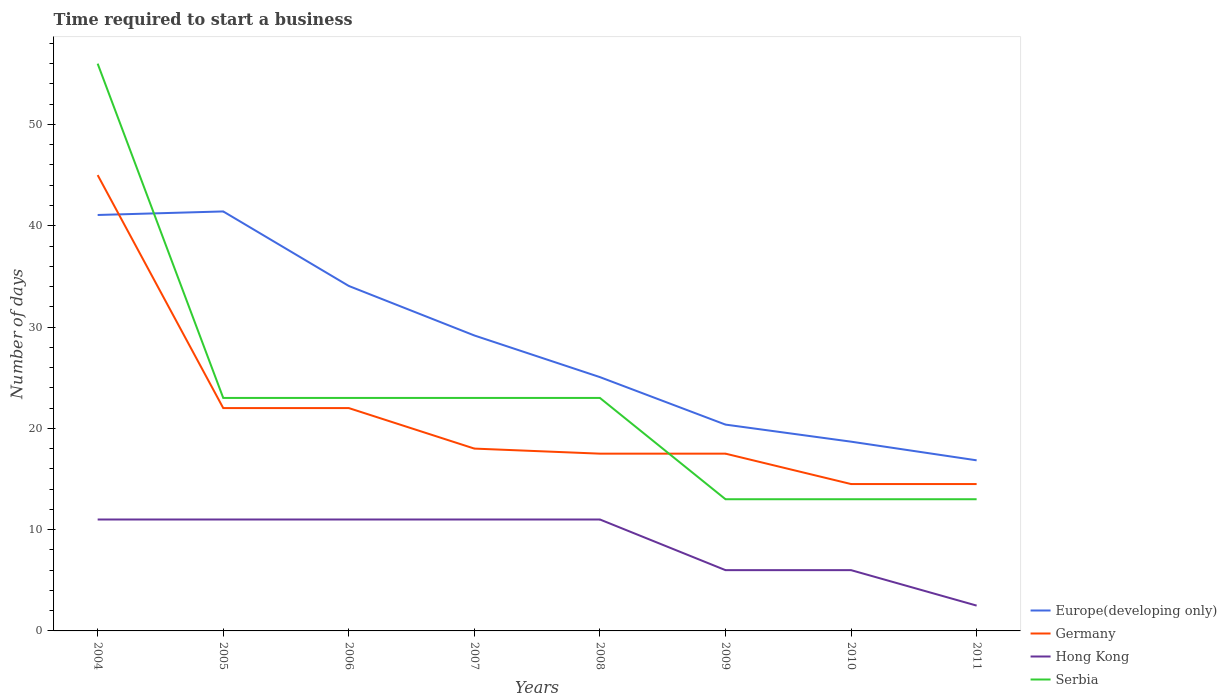How many different coloured lines are there?
Ensure brevity in your answer.  4. Is the number of lines equal to the number of legend labels?
Your response must be concise. Yes. Across all years, what is the maximum number of days required to start a business in Serbia?
Offer a terse response. 13. What is the total number of days required to start a business in Europe(developing only) in the graph?
Make the answer very short. 17.21. What is the difference between the highest and the second highest number of days required to start a business in Serbia?
Provide a succinct answer. 43. What is the difference between the highest and the lowest number of days required to start a business in Europe(developing only)?
Ensure brevity in your answer.  4. Is the number of days required to start a business in Hong Kong strictly greater than the number of days required to start a business in Serbia over the years?
Make the answer very short. Yes. How many lines are there?
Provide a succinct answer. 4. How many years are there in the graph?
Provide a short and direct response. 8. Are the values on the major ticks of Y-axis written in scientific E-notation?
Offer a terse response. No. Does the graph contain any zero values?
Give a very brief answer. No. How many legend labels are there?
Keep it short and to the point. 4. How are the legend labels stacked?
Offer a terse response. Vertical. What is the title of the graph?
Offer a very short reply. Time required to start a business. What is the label or title of the Y-axis?
Give a very brief answer. Number of days. What is the Number of days of Europe(developing only) in 2004?
Your response must be concise. 41.06. What is the Number of days in Hong Kong in 2004?
Offer a very short reply. 11. What is the Number of days in Europe(developing only) in 2005?
Offer a very short reply. 41.41. What is the Number of days in Germany in 2005?
Offer a terse response. 22. What is the Number of days of Europe(developing only) in 2006?
Provide a short and direct response. 34.06. What is the Number of days of Hong Kong in 2006?
Your answer should be compact. 11. What is the Number of days of Europe(developing only) in 2007?
Make the answer very short. 29.17. What is the Number of days in Hong Kong in 2007?
Give a very brief answer. 11. What is the Number of days in Europe(developing only) in 2008?
Your answer should be compact. 25.06. What is the Number of days in Hong Kong in 2008?
Make the answer very short. 11. What is the Number of days in Europe(developing only) in 2009?
Give a very brief answer. 20.37. What is the Number of days in Germany in 2009?
Ensure brevity in your answer.  17.5. What is the Number of days in Europe(developing only) in 2010?
Your answer should be very brief. 18.68. What is the Number of days in Hong Kong in 2010?
Provide a succinct answer. 6. What is the Number of days of Europe(developing only) in 2011?
Offer a terse response. 16.84. What is the Number of days of Germany in 2011?
Offer a very short reply. 14.5. What is the Number of days of Serbia in 2011?
Keep it short and to the point. 13. Across all years, what is the maximum Number of days of Europe(developing only)?
Make the answer very short. 41.41. Across all years, what is the maximum Number of days in Germany?
Keep it short and to the point. 45. Across all years, what is the minimum Number of days of Europe(developing only)?
Your answer should be compact. 16.84. Across all years, what is the minimum Number of days of Germany?
Ensure brevity in your answer.  14.5. What is the total Number of days of Europe(developing only) in the graph?
Provide a succinct answer. 226.65. What is the total Number of days in Germany in the graph?
Keep it short and to the point. 171. What is the total Number of days in Hong Kong in the graph?
Your answer should be compact. 69.5. What is the total Number of days of Serbia in the graph?
Give a very brief answer. 187. What is the difference between the Number of days in Europe(developing only) in 2004 and that in 2005?
Offer a very short reply. -0.35. What is the difference between the Number of days of Germany in 2004 and that in 2005?
Offer a terse response. 23. What is the difference between the Number of days in Hong Kong in 2004 and that in 2005?
Keep it short and to the point. 0. What is the difference between the Number of days of Europe(developing only) in 2004 and that in 2006?
Ensure brevity in your answer.  7.01. What is the difference between the Number of days of Germany in 2004 and that in 2006?
Provide a short and direct response. 23. What is the difference between the Number of days of Hong Kong in 2004 and that in 2006?
Keep it short and to the point. 0. What is the difference between the Number of days in Europe(developing only) in 2004 and that in 2007?
Your answer should be compact. 11.9. What is the difference between the Number of days of Europe(developing only) in 2004 and that in 2008?
Make the answer very short. 16.01. What is the difference between the Number of days of Germany in 2004 and that in 2008?
Keep it short and to the point. 27.5. What is the difference between the Number of days in Europe(developing only) in 2004 and that in 2009?
Provide a succinct answer. 20.69. What is the difference between the Number of days in Germany in 2004 and that in 2009?
Your answer should be very brief. 27.5. What is the difference between the Number of days in Hong Kong in 2004 and that in 2009?
Offer a very short reply. 5. What is the difference between the Number of days in Serbia in 2004 and that in 2009?
Offer a terse response. 43. What is the difference between the Number of days in Europe(developing only) in 2004 and that in 2010?
Provide a short and direct response. 22.38. What is the difference between the Number of days in Germany in 2004 and that in 2010?
Offer a very short reply. 30.5. What is the difference between the Number of days of Hong Kong in 2004 and that in 2010?
Provide a succinct answer. 5. What is the difference between the Number of days of Europe(developing only) in 2004 and that in 2011?
Offer a very short reply. 24.22. What is the difference between the Number of days in Germany in 2004 and that in 2011?
Your answer should be very brief. 30.5. What is the difference between the Number of days of Serbia in 2004 and that in 2011?
Offer a terse response. 43. What is the difference between the Number of days in Europe(developing only) in 2005 and that in 2006?
Make the answer very short. 7.36. What is the difference between the Number of days in Hong Kong in 2005 and that in 2006?
Ensure brevity in your answer.  0. What is the difference between the Number of days in Serbia in 2005 and that in 2006?
Your response must be concise. 0. What is the difference between the Number of days of Europe(developing only) in 2005 and that in 2007?
Your answer should be very brief. 12.25. What is the difference between the Number of days of Germany in 2005 and that in 2007?
Keep it short and to the point. 4. What is the difference between the Number of days of Hong Kong in 2005 and that in 2007?
Offer a very short reply. 0. What is the difference between the Number of days in Serbia in 2005 and that in 2007?
Give a very brief answer. 0. What is the difference between the Number of days in Europe(developing only) in 2005 and that in 2008?
Provide a succinct answer. 16.36. What is the difference between the Number of days of Germany in 2005 and that in 2008?
Your answer should be compact. 4.5. What is the difference between the Number of days of Europe(developing only) in 2005 and that in 2009?
Your answer should be compact. 21.04. What is the difference between the Number of days in Europe(developing only) in 2005 and that in 2010?
Ensure brevity in your answer.  22.73. What is the difference between the Number of days of Germany in 2005 and that in 2010?
Offer a terse response. 7.5. What is the difference between the Number of days in Europe(developing only) in 2005 and that in 2011?
Provide a short and direct response. 24.57. What is the difference between the Number of days of Serbia in 2005 and that in 2011?
Your response must be concise. 10. What is the difference between the Number of days in Europe(developing only) in 2006 and that in 2007?
Provide a short and direct response. 4.89. What is the difference between the Number of days in Serbia in 2006 and that in 2007?
Provide a succinct answer. 0. What is the difference between the Number of days in Europe(developing only) in 2006 and that in 2008?
Your response must be concise. 9. What is the difference between the Number of days in Germany in 2006 and that in 2008?
Keep it short and to the point. 4.5. What is the difference between the Number of days in Hong Kong in 2006 and that in 2008?
Your answer should be compact. 0. What is the difference between the Number of days of Europe(developing only) in 2006 and that in 2009?
Make the answer very short. 13.69. What is the difference between the Number of days of Serbia in 2006 and that in 2009?
Provide a short and direct response. 10. What is the difference between the Number of days of Europe(developing only) in 2006 and that in 2010?
Make the answer very short. 15.37. What is the difference between the Number of days of Hong Kong in 2006 and that in 2010?
Provide a short and direct response. 5. What is the difference between the Number of days of Europe(developing only) in 2006 and that in 2011?
Make the answer very short. 17.21. What is the difference between the Number of days of Germany in 2006 and that in 2011?
Make the answer very short. 7.5. What is the difference between the Number of days of Hong Kong in 2006 and that in 2011?
Provide a succinct answer. 8.5. What is the difference between the Number of days of Europe(developing only) in 2007 and that in 2008?
Your response must be concise. 4.11. What is the difference between the Number of days in Germany in 2007 and that in 2008?
Give a very brief answer. 0.5. What is the difference between the Number of days of Hong Kong in 2007 and that in 2008?
Your response must be concise. 0. What is the difference between the Number of days of Serbia in 2007 and that in 2008?
Ensure brevity in your answer.  0. What is the difference between the Number of days of Europe(developing only) in 2007 and that in 2009?
Provide a succinct answer. 8.8. What is the difference between the Number of days in Serbia in 2007 and that in 2009?
Keep it short and to the point. 10. What is the difference between the Number of days of Europe(developing only) in 2007 and that in 2010?
Offer a terse response. 10.48. What is the difference between the Number of days in Hong Kong in 2007 and that in 2010?
Your response must be concise. 5. What is the difference between the Number of days in Europe(developing only) in 2007 and that in 2011?
Make the answer very short. 12.32. What is the difference between the Number of days of Serbia in 2007 and that in 2011?
Make the answer very short. 10. What is the difference between the Number of days in Europe(developing only) in 2008 and that in 2009?
Keep it short and to the point. 4.69. What is the difference between the Number of days of Europe(developing only) in 2008 and that in 2010?
Offer a terse response. 6.37. What is the difference between the Number of days in Europe(developing only) in 2008 and that in 2011?
Your answer should be compact. 8.21. What is the difference between the Number of days in Germany in 2008 and that in 2011?
Offer a very short reply. 3. What is the difference between the Number of days of Hong Kong in 2008 and that in 2011?
Offer a very short reply. 8.5. What is the difference between the Number of days of Europe(developing only) in 2009 and that in 2010?
Offer a very short reply. 1.68. What is the difference between the Number of days in Europe(developing only) in 2009 and that in 2011?
Your response must be concise. 3.53. What is the difference between the Number of days in Germany in 2009 and that in 2011?
Your answer should be very brief. 3. What is the difference between the Number of days in Europe(developing only) in 2010 and that in 2011?
Keep it short and to the point. 1.84. What is the difference between the Number of days of Germany in 2010 and that in 2011?
Ensure brevity in your answer.  0. What is the difference between the Number of days in Europe(developing only) in 2004 and the Number of days in Germany in 2005?
Provide a succinct answer. 19.06. What is the difference between the Number of days in Europe(developing only) in 2004 and the Number of days in Hong Kong in 2005?
Make the answer very short. 30.06. What is the difference between the Number of days of Europe(developing only) in 2004 and the Number of days of Serbia in 2005?
Your answer should be compact. 18.06. What is the difference between the Number of days of Germany in 2004 and the Number of days of Hong Kong in 2005?
Keep it short and to the point. 34. What is the difference between the Number of days of Germany in 2004 and the Number of days of Serbia in 2005?
Your answer should be compact. 22. What is the difference between the Number of days of Europe(developing only) in 2004 and the Number of days of Germany in 2006?
Give a very brief answer. 19.06. What is the difference between the Number of days in Europe(developing only) in 2004 and the Number of days in Hong Kong in 2006?
Provide a short and direct response. 30.06. What is the difference between the Number of days in Europe(developing only) in 2004 and the Number of days in Serbia in 2006?
Provide a succinct answer. 18.06. What is the difference between the Number of days in Germany in 2004 and the Number of days in Serbia in 2006?
Your response must be concise. 22. What is the difference between the Number of days in Hong Kong in 2004 and the Number of days in Serbia in 2006?
Offer a very short reply. -12. What is the difference between the Number of days in Europe(developing only) in 2004 and the Number of days in Germany in 2007?
Give a very brief answer. 23.06. What is the difference between the Number of days in Europe(developing only) in 2004 and the Number of days in Hong Kong in 2007?
Make the answer very short. 30.06. What is the difference between the Number of days in Europe(developing only) in 2004 and the Number of days in Serbia in 2007?
Make the answer very short. 18.06. What is the difference between the Number of days of Germany in 2004 and the Number of days of Hong Kong in 2007?
Your answer should be very brief. 34. What is the difference between the Number of days in Germany in 2004 and the Number of days in Serbia in 2007?
Provide a succinct answer. 22. What is the difference between the Number of days of Europe(developing only) in 2004 and the Number of days of Germany in 2008?
Your answer should be compact. 23.56. What is the difference between the Number of days in Europe(developing only) in 2004 and the Number of days in Hong Kong in 2008?
Your answer should be very brief. 30.06. What is the difference between the Number of days in Europe(developing only) in 2004 and the Number of days in Serbia in 2008?
Ensure brevity in your answer.  18.06. What is the difference between the Number of days in Germany in 2004 and the Number of days in Hong Kong in 2008?
Offer a terse response. 34. What is the difference between the Number of days in Hong Kong in 2004 and the Number of days in Serbia in 2008?
Your answer should be very brief. -12. What is the difference between the Number of days of Europe(developing only) in 2004 and the Number of days of Germany in 2009?
Make the answer very short. 23.56. What is the difference between the Number of days in Europe(developing only) in 2004 and the Number of days in Hong Kong in 2009?
Offer a very short reply. 35.06. What is the difference between the Number of days of Europe(developing only) in 2004 and the Number of days of Serbia in 2009?
Your response must be concise. 28.06. What is the difference between the Number of days in Europe(developing only) in 2004 and the Number of days in Germany in 2010?
Offer a very short reply. 26.56. What is the difference between the Number of days of Europe(developing only) in 2004 and the Number of days of Hong Kong in 2010?
Offer a very short reply. 35.06. What is the difference between the Number of days in Europe(developing only) in 2004 and the Number of days in Serbia in 2010?
Offer a very short reply. 28.06. What is the difference between the Number of days in Germany in 2004 and the Number of days in Hong Kong in 2010?
Provide a succinct answer. 39. What is the difference between the Number of days of Germany in 2004 and the Number of days of Serbia in 2010?
Your answer should be compact. 32. What is the difference between the Number of days of Europe(developing only) in 2004 and the Number of days of Germany in 2011?
Your answer should be compact. 26.56. What is the difference between the Number of days of Europe(developing only) in 2004 and the Number of days of Hong Kong in 2011?
Your answer should be compact. 38.56. What is the difference between the Number of days of Europe(developing only) in 2004 and the Number of days of Serbia in 2011?
Ensure brevity in your answer.  28.06. What is the difference between the Number of days in Germany in 2004 and the Number of days in Hong Kong in 2011?
Ensure brevity in your answer.  42.5. What is the difference between the Number of days of Hong Kong in 2004 and the Number of days of Serbia in 2011?
Keep it short and to the point. -2. What is the difference between the Number of days in Europe(developing only) in 2005 and the Number of days in Germany in 2006?
Your answer should be very brief. 19.41. What is the difference between the Number of days of Europe(developing only) in 2005 and the Number of days of Hong Kong in 2006?
Your answer should be very brief. 30.41. What is the difference between the Number of days of Europe(developing only) in 2005 and the Number of days of Serbia in 2006?
Provide a succinct answer. 18.41. What is the difference between the Number of days in Hong Kong in 2005 and the Number of days in Serbia in 2006?
Keep it short and to the point. -12. What is the difference between the Number of days in Europe(developing only) in 2005 and the Number of days in Germany in 2007?
Provide a succinct answer. 23.41. What is the difference between the Number of days of Europe(developing only) in 2005 and the Number of days of Hong Kong in 2007?
Offer a terse response. 30.41. What is the difference between the Number of days of Europe(developing only) in 2005 and the Number of days of Serbia in 2007?
Offer a terse response. 18.41. What is the difference between the Number of days of Germany in 2005 and the Number of days of Hong Kong in 2007?
Your answer should be compact. 11. What is the difference between the Number of days of Europe(developing only) in 2005 and the Number of days of Germany in 2008?
Offer a terse response. 23.91. What is the difference between the Number of days in Europe(developing only) in 2005 and the Number of days in Hong Kong in 2008?
Keep it short and to the point. 30.41. What is the difference between the Number of days in Europe(developing only) in 2005 and the Number of days in Serbia in 2008?
Provide a succinct answer. 18.41. What is the difference between the Number of days of Germany in 2005 and the Number of days of Hong Kong in 2008?
Provide a succinct answer. 11. What is the difference between the Number of days of Europe(developing only) in 2005 and the Number of days of Germany in 2009?
Ensure brevity in your answer.  23.91. What is the difference between the Number of days of Europe(developing only) in 2005 and the Number of days of Hong Kong in 2009?
Give a very brief answer. 35.41. What is the difference between the Number of days in Europe(developing only) in 2005 and the Number of days in Serbia in 2009?
Your response must be concise. 28.41. What is the difference between the Number of days of Germany in 2005 and the Number of days of Hong Kong in 2009?
Offer a very short reply. 16. What is the difference between the Number of days of Germany in 2005 and the Number of days of Serbia in 2009?
Your answer should be very brief. 9. What is the difference between the Number of days of Hong Kong in 2005 and the Number of days of Serbia in 2009?
Your answer should be compact. -2. What is the difference between the Number of days of Europe(developing only) in 2005 and the Number of days of Germany in 2010?
Keep it short and to the point. 26.91. What is the difference between the Number of days in Europe(developing only) in 2005 and the Number of days in Hong Kong in 2010?
Your response must be concise. 35.41. What is the difference between the Number of days in Europe(developing only) in 2005 and the Number of days in Serbia in 2010?
Offer a terse response. 28.41. What is the difference between the Number of days of Hong Kong in 2005 and the Number of days of Serbia in 2010?
Provide a succinct answer. -2. What is the difference between the Number of days in Europe(developing only) in 2005 and the Number of days in Germany in 2011?
Make the answer very short. 26.91. What is the difference between the Number of days in Europe(developing only) in 2005 and the Number of days in Hong Kong in 2011?
Your answer should be compact. 38.91. What is the difference between the Number of days of Europe(developing only) in 2005 and the Number of days of Serbia in 2011?
Offer a terse response. 28.41. What is the difference between the Number of days of Germany in 2005 and the Number of days of Hong Kong in 2011?
Ensure brevity in your answer.  19.5. What is the difference between the Number of days in Germany in 2005 and the Number of days in Serbia in 2011?
Your answer should be very brief. 9. What is the difference between the Number of days in Europe(developing only) in 2006 and the Number of days in Germany in 2007?
Make the answer very short. 16.06. What is the difference between the Number of days of Europe(developing only) in 2006 and the Number of days of Hong Kong in 2007?
Your answer should be compact. 23.06. What is the difference between the Number of days of Europe(developing only) in 2006 and the Number of days of Serbia in 2007?
Keep it short and to the point. 11.06. What is the difference between the Number of days of Hong Kong in 2006 and the Number of days of Serbia in 2007?
Your answer should be very brief. -12. What is the difference between the Number of days in Europe(developing only) in 2006 and the Number of days in Germany in 2008?
Offer a very short reply. 16.56. What is the difference between the Number of days of Europe(developing only) in 2006 and the Number of days of Hong Kong in 2008?
Keep it short and to the point. 23.06. What is the difference between the Number of days in Europe(developing only) in 2006 and the Number of days in Serbia in 2008?
Ensure brevity in your answer.  11.06. What is the difference between the Number of days of Germany in 2006 and the Number of days of Serbia in 2008?
Offer a terse response. -1. What is the difference between the Number of days in Hong Kong in 2006 and the Number of days in Serbia in 2008?
Offer a very short reply. -12. What is the difference between the Number of days of Europe(developing only) in 2006 and the Number of days of Germany in 2009?
Keep it short and to the point. 16.56. What is the difference between the Number of days of Europe(developing only) in 2006 and the Number of days of Hong Kong in 2009?
Your response must be concise. 28.06. What is the difference between the Number of days of Europe(developing only) in 2006 and the Number of days of Serbia in 2009?
Provide a succinct answer. 21.06. What is the difference between the Number of days in Germany in 2006 and the Number of days in Hong Kong in 2009?
Offer a very short reply. 16. What is the difference between the Number of days in Germany in 2006 and the Number of days in Serbia in 2009?
Provide a short and direct response. 9. What is the difference between the Number of days of Hong Kong in 2006 and the Number of days of Serbia in 2009?
Provide a short and direct response. -2. What is the difference between the Number of days of Europe(developing only) in 2006 and the Number of days of Germany in 2010?
Your answer should be compact. 19.56. What is the difference between the Number of days of Europe(developing only) in 2006 and the Number of days of Hong Kong in 2010?
Provide a succinct answer. 28.06. What is the difference between the Number of days in Europe(developing only) in 2006 and the Number of days in Serbia in 2010?
Keep it short and to the point. 21.06. What is the difference between the Number of days of Germany in 2006 and the Number of days of Serbia in 2010?
Keep it short and to the point. 9. What is the difference between the Number of days of Hong Kong in 2006 and the Number of days of Serbia in 2010?
Ensure brevity in your answer.  -2. What is the difference between the Number of days in Europe(developing only) in 2006 and the Number of days in Germany in 2011?
Make the answer very short. 19.56. What is the difference between the Number of days in Europe(developing only) in 2006 and the Number of days in Hong Kong in 2011?
Make the answer very short. 31.56. What is the difference between the Number of days in Europe(developing only) in 2006 and the Number of days in Serbia in 2011?
Your answer should be compact. 21.06. What is the difference between the Number of days in Europe(developing only) in 2007 and the Number of days in Germany in 2008?
Give a very brief answer. 11.67. What is the difference between the Number of days in Europe(developing only) in 2007 and the Number of days in Hong Kong in 2008?
Keep it short and to the point. 18.17. What is the difference between the Number of days in Europe(developing only) in 2007 and the Number of days in Serbia in 2008?
Offer a terse response. 6.17. What is the difference between the Number of days in Hong Kong in 2007 and the Number of days in Serbia in 2008?
Give a very brief answer. -12. What is the difference between the Number of days of Europe(developing only) in 2007 and the Number of days of Germany in 2009?
Offer a very short reply. 11.67. What is the difference between the Number of days of Europe(developing only) in 2007 and the Number of days of Hong Kong in 2009?
Keep it short and to the point. 23.17. What is the difference between the Number of days in Europe(developing only) in 2007 and the Number of days in Serbia in 2009?
Keep it short and to the point. 16.17. What is the difference between the Number of days in Germany in 2007 and the Number of days in Hong Kong in 2009?
Your answer should be compact. 12. What is the difference between the Number of days of Germany in 2007 and the Number of days of Serbia in 2009?
Give a very brief answer. 5. What is the difference between the Number of days in Europe(developing only) in 2007 and the Number of days in Germany in 2010?
Make the answer very short. 14.67. What is the difference between the Number of days of Europe(developing only) in 2007 and the Number of days of Hong Kong in 2010?
Your answer should be compact. 23.17. What is the difference between the Number of days in Europe(developing only) in 2007 and the Number of days in Serbia in 2010?
Provide a short and direct response. 16.17. What is the difference between the Number of days of Germany in 2007 and the Number of days of Hong Kong in 2010?
Keep it short and to the point. 12. What is the difference between the Number of days of Europe(developing only) in 2007 and the Number of days of Germany in 2011?
Your response must be concise. 14.67. What is the difference between the Number of days of Europe(developing only) in 2007 and the Number of days of Hong Kong in 2011?
Give a very brief answer. 26.67. What is the difference between the Number of days in Europe(developing only) in 2007 and the Number of days in Serbia in 2011?
Make the answer very short. 16.17. What is the difference between the Number of days in Germany in 2007 and the Number of days in Serbia in 2011?
Provide a succinct answer. 5. What is the difference between the Number of days in Europe(developing only) in 2008 and the Number of days in Germany in 2009?
Your response must be concise. 7.56. What is the difference between the Number of days of Europe(developing only) in 2008 and the Number of days of Hong Kong in 2009?
Make the answer very short. 19.06. What is the difference between the Number of days in Europe(developing only) in 2008 and the Number of days in Serbia in 2009?
Your answer should be compact. 12.06. What is the difference between the Number of days of Germany in 2008 and the Number of days of Hong Kong in 2009?
Offer a very short reply. 11.5. What is the difference between the Number of days of Germany in 2008 and the Number of days of Serbia in 2009?
Your response must be concise. 4.5. What is the difference between the Number of days of Hong Kong in 2008 and the Number of days of Serbia in 2009?
Provide a short and direct response. -2. What is the difference between the Number of days of Europe(developing only) in 2008 and the Number of days of Germany in 2010?
Provide a succinct answer. 10.56. What is the difference between the Number of days of Europe(developing only) in 2008 and the Number of days of Hong Kong in 2010?
Ensure brevity in your answer.  19.06. What is the difference between the Number of days in Europe(developing only) in 2008 and the Number of days in Serbia in 2010?
Your answer should be compact. 12.06. What is the difference between the Number of days of Europe(developing only) in 2008 and the Number of days of Germany in 2011?
Provide a short and direct response. 10.56. What is the difference between the Number of days of Europe(developing only) in 2008 and the Number of days of Hong Kong in 2011?
Your response must be concise. 22.56. What is the difference between the Number of days in Europe(developing only) in 2008 and the Number of days in Serbia in 2011?
Your response must be concise. 12.06. What is the difference between the Number of days of Germany in 2008 and the Number of days of Hong Kong in 2011?
Offer a very short reply. 15. What is the difference between the Number of days of Hong Kong in 2008 and the Number of days of Serbia in 2011?
Provide a short and direct response. -2. What is the difference between the Number of days of Europe(developing only) in 2009 and the Number of days of Germany in 2010?
Provide a short and direct response. 5.87. What is the difference between the Number of days of Europe(developing only) in 2009 and the Number of days of Hong Kong in 2010?
Keep it short and to the point. 14.37. What is the difference between the Number of days of Europe(developing only) in 2009 and the Number of days of Serbia in 2010?
Provide a succinct answer. 7.37. What is the difference between the Number of days of Germany in 2009 and the Number of days of Hong Kong in 2010?
Your answer should be very brief. 11.5. What is the difference between the Number of days of Germany in 2009 and the Number of days of Serbia in 2010?
Keep it short and to the point. 4.5. What is the difference between the Number of days in Europe(developing only) in 2009 and the Number of days in Germany in 2011?
Provide a short and direct response. 5.87. What is the difference between the Number of days in Europe(developing only) in 2009 and the Number of days in Hong Kong in 2011?
Offer a terse response. 17.87. What is the difference between the Number of days of Europe(developing only) in 2009 and the Number of days of Serbia in 2011?
Provide a short and direct response. 7.37. What is the difference between the Number of days in Europe(developing only) in 2010 and the Number of days in Germany in 2011?
Offer a very short reply. 4.18. What is the difference between the Number of days in Europe(developing only) in 2010 and the Number of days in Hong Kong in 2011?
Your answer should be compact. 16.18. What is the difference between the Number of days of Europe(developing only) in 2010 and the Number of days of Serbia in 2011?
Your answer should be compact. 5.68. What is the difference between the Number of days of Germany in 2010 and the Number of days of Serbia in 2011?
Offer a very short reply. 1.5. What is the average Number of days in Europe(developing only) per year?
Give a very brief answer. 28.33. What is the average Number of days of Germany per year?
Provide a short and direct response. 21.38. What is the average Number of days of Hong Kong per year?
Your response must be concise. 8.69. What is the average Number of days of Serbia per year?
Provide a short and direct response. 23.38. In the year 2004, what is the difference between the Number of days of Europe(developing only) and Number of days of Germany?
Keep it short and to the point. -3.94. In the year 2004, what is the difference between the Number of days of Europe(developing only) and Number of days of Hong Kong?
Give a very brief answer. 30.06. In the year 2004, what is the difference between the Number of days of Europe(developing only) and Number of days of Serbia?
Provide a succinct answer. -14.94. In the year 2004, what is the difference between the Number of days in Germany and Number of days in Hong Kong?
Provide a short and direct response. 34. In the year 2004, what is the difference between the Number of days in Germany and Number of days in Serbia?
Your answer should be very brief. -11. In the year 2004, what is the difference between the Number of days of Hong Kong and Number of days of Serbia?
Make the answer very short. -45. In the year 2005, what is the difference between the Number of days in Europe(developing only) and Number of days in Germany?
Ensure brevity in your answer.  19.41. In the year 2005, what is the difference between the Number of days in Europe(developing only) and Number of days in Hong Kong?
Provide a short and direct response. 30.41. In the year 2005, what is the difference between the Number of days in Europe(developing only) and Number of days in Serbia?
Offer a very short reply. 18.41. In the year 2005, what is the difference between the Number of days in Germany and Number of days in Hong Kong?
Give a very brief answer. 11. In the year 2005, what is the difference between the Number of days in Hong Kong and Number of days in Serbia?
Your response must be concise. -12. In the year 2006, what is the difference between the Number of days in Europe(developing only) and Number of days in Germany?
Provide a succinct answer. 12.06. In the year 2006, what is the difference between the Number of days of Europe(developing only) and Number of days of Hong Kong?
Keep it short and to the point. 23.06. In the year 2006, what is the difference between the Number of days in Europe(developing only) and Number of days in Serbia?
Offer a very short reply. 11.06. In the year 2007, what is the difference between the Number of days in Europe(developing only) and Number of days in Germany?
Your answer should be very brief. 11.17. In the year 2007, what is the difference between the Number of days of Europe(developing only) and Number of days of Hong Kong?
Offer a very short reply. 18.17. In the year 2007, what is the difference between the Number of days in Europe(developing only) and Number of days in Serbia?
Your response must be concise. 6.17. In the year 2008, what is the difference between the Number of days in Europe(developing only) and Number of days in Germany?
Keep it short and to the point. 7.56. In the year 2008, what is the difference between the Number of days in Europe(developing only) and Number of days in Hong Kong?
Your answer should be very brief. 14.06. In the year 2008, what is the difference between the Number of days in Europe(developing only) and Number of days in Serbia?
Your response must be concise. 2.06. In the year 2008, what is the difference between the Number of days in Hong Kong and Number of days in Serbia?
Offer a terse response. -12. In the year 2009, what is the difference between the Number of days of Europe(developing only) and Number of days of Germany?
Ensure brevity in your answer.  2.87. In the year 2009, what is the difference between the Number of days of Europe(developing only) and Number of days of Hong Kong?
Offer a terse response. 14.37. In the year 2009, what is the difference between the Number of days in Europe(developing only) and Number of days in Serbia?
Your response must be concise. 7.37. In the year 2009, what is the difference between the Number of days of Germany and Number of days of Hong Kong?
Your answer should be very brief. 11.5. In the year 2009, what is the difference between the Number of days in Germany and Number of days in Serbia?
Make the answer very short. 4.5. In the year 2009, what is the difference between the Number of days of Hong Kong and Number of days of Serbia?
Offer a terse response. -7. In the year 2010, what is the difference between the Number of days in Europe(developing only) and Number of days in Germany?
Offer a terse response. 4.18. In the year 2010, what is the difference between the Number of days of Europe(developing only) and Number of days of Hong Kong?
Your answer should be compact. 12.68. In the year 2010, what is the difference between the Number of days in Europe(developing only) and Number of days in Serbia?
Keep it short and to the point. 5.68. In the year 2010, what is the difference between the Number of days of Hong Kong and Number of days of Serbia?
Your answer should be very brief. -7. In the year 2011, what is the difference between the Number of days in Europe(developing only) and Number of days in Germany?
Make the answer very short. 2.34. In the year 2011, what is the difference between the Number of days of Europe(developing only) and Number of days of Hong Kong?
Provide a succinct answer. 14.34. In the year 2011, what is the difference between the Number of days of Europe(developing only) and Number of days of Serbia?
Ensure brevity in your answer.  3.84. In the year 2011, what is the difference between the Number of days of Germany and Number of days of Hong Kong?
Your answer should be compact. 12. In the year 2011, what is the difference between the Number of days of Germany and Number of days of Serbia?
Ensure brevity in your answer.  1.5. In the year 2011, what is the difference between the Number of days of Hong Kong and Number of days of Serbia?
Ensure brevity in your answer.  -10.5. What is the ratio of the Number of days of Europe(developing only) in 2004 to that in 2005?
Your answer should be very brief. 0.99. What is the ratio of the Number of days in Germany in 2004 to that in 2005?
Give a very brief answer. 2.05. What is the ratio of the Number of days in Serbia in 2004 to that in 2005?
Offer a very short reply. 2.43. What is the ratio of the Number of days in Europe(developing only) in 2004 to that in 2006?
Offer a terse response. 1.21. What is the ratio of the Number of days in Germany in 2004 to that in 2006?
Your answer should be very brief. 2.05. What is the ratio of the Number of days in Serbia in 2004 to that in 2006?
Provide a succinct answer. 2.43. What is the ratio of the Number of days of Europe(developing only) in 2004 to that in 2007?
Your response must be concise. 1.41. What is the ratio of the Number of days in Serbia in 2004 to that in 2007?
Your answer should be very brief. 2.43. What is the ratio of the Number of days of Europe(developing only) in 2004 to that in 2008?
Ensure brevity in your answer.  1.64. What is the ratio of the Number of days of Germany in 2004 to that in 2008?
Give a very brief answer. 2.57. What is the ratio of the Number of days of Hong Kong in 2004 to that in 2008?
Give a very brief answer. 1. What is the ratio of the Number of days of Serbia in 2004 to that in 2008?
Offer a very short reply. 2.43. What is the ratio of the Number of days in Europe(developing only) in 2004 to that in 2009?
Your answer should be compact. 2.02. What is the ratio of the Number of days of Germany in 2004 to that in 2009?
Your answer should be very brief. 2.57. What is the ratio of the Number of days in Hong Kong in 2004 to that in 2009?
Ensure brevity in your answer.  1.83. What is the ratio of the Number of days in Serbia in 2004 to that in 2009?
Keep it short and to the point. 4.31. What is the ratio of the Number of days of Europe(developing only) in 2004 to that in 2010?
Your response must be concise. 2.2. What is the ratio of the Number of days of Germany in 2004 to that in 2010?
Your answer should be compact. 3.1. What is the ratio of the Number of days of Hong Kong in 2004 to that in 2010?
Your response must be concise. 1.83. What is the ratio of the Number of days in Serbia in 2004 to that in 2010?
Keep it short and to the point. 4.31. What is the ratio of the Number of days in Europe(developing only) in 2004 to that in 2011?
Your response must be concise. 2.44. What is the ratio of the Number of days in Germany in 2004 to that in 2011?
Make the answer very short. 3.1. What is the ratio of the Number of days of Serbia in 2004 to that in 2011?
Your answer should be very brief. 4.31. What is the ratio of the Number of days in Europe(developing only) in 2005 to that in 2006?
Your answer should be very brief. 1.22. What is the ratio of the Number of days of Serbia in 2005 to that in 2006?
Your response must be concise. 1. What is the ratio of the Number of days of Europe(developing only) in 2005 to that in 2007?
Ensure brevity in your answer.  1.42. What is the ratio of the Number of days of Germany in 2005 to that in 2007?
Give a very brief answer. 1.22. What is the ratio of the Number of days in Hong Kong in 2005 to that in 2007?
Ensure brevity in your answer.  1. What is the ratio of the Number of days of Europe(developing only) in 2005 to that in 2008?
Make the answer very short. 1.65. What is the ratio of the Number of days in Germany in 2005 to that in 2008?
Your answer should be very brief. 1.26. What is the ratio of the Number of days of Hong Kong in 2005 to that in 2008?
Give a very brief answer. 1. What is the ratio of the Number of days in Europe(developing only) in 2005 to that in 2009?
Ensure brevity in your answer.  2.03. What is the ratio of the Number of days of Germany in 2005 to that in 2009?
Provide a short and direct response. 1.26. What is the ratio of the Number of days in Hong Kong in 2005 to that in 2009?
Your answer should be compact. 1.83. What is the ratio of the Number of days in Serbia in 2005 to that in 2009?
Your response must be concise. 1.77. What is the ratio of the Number of days in Europe(developing only) in 2005 to that in 2010?
Your response must be concise. 2.22. What is the ratio of the Number of days in Germany in 2005 to that in 2010?
Offer a terse response. 1.52. What is the ratio of the Number of days in Hong Kong in 2005 to that in 2010?
Ensure brevity in your answer.  1.83. What is the ratio of the Number of days in Serbia in 2005 to that in 2010?
Ensure brevity in your answer.  1.77. What is the ratio of the Number of days of Europe(developing only) in 2005 to that in 2011?
Keep it short and to the point. 2.46. What is the ratio of the Number of days in Germany in 2005 to that in 2011?
Your answer should be very brief. 1.52. What is the ratio of the Number of days in Serbia in 2005 to that in 2011?
Provide a succinct answer. 1.77. What is the ratio of the Number of days in Europe(developing only) in 2006 to that in 2007?
Your answer should be compact. 1.17. What is the ratio of the Number of days in Germany in 2006 to that in 2007?
Your answer should be very brief. 1.22. What is the ratio of the Number of days of Hong Kong in 2006 to that in 2007?
Make the answer very short. 1. What is the ratio of the Number of days of Europe(developing only) in 2006 to that in 2008?
Keep it short and to the point. 1.36. What is the ratio of the Number of days in Germany in 2006 to that in 2008?
Make the answer very short. 1.26. What is the ratio of the Number of days of Serbia in 2006 to that in 2008?
Provide a succinct answer. 1. What is the ratio of the Number of days in Europe(developing only) in 2006 to that in 2009?
Provide a short and direct response. 1.67. What is the ratio of the Number of days in Germany in 2006 to that in 2009?
Your response must be concise. 1.26. What is the ratio of the Number of days in Hong Kong in 2006 to that in 2009?
Make the answer very short. 1.83. What is the ratio of the Number of days in Serbia in 2006 to that in 2009?
Your answer should be compact. 1.77. What is the ratio of the Number of days of Europe(developing only) in 2006 to that in 2010?
Your response must be concise. 1.82. What is the ratio of the Number of days in Germany in 2006 to that in 2010?
Keep it short and to the point. 1.52. What is the ratio of the Number of days of Hong Kong in 2006 to that in 2010?
Give a very brief answer. 1.83. What is the ratio of the Number of days in Serbia in 2006 to that in 2010?
Your answer should be compact. 1.77. What is the ratio of the Number of days in Europe(developing only) in 2006 to that in 2011?
Your response must be concise. 2.02. What is the ratio of the Number of days of Germany in 2006 to that in 2011?
Provide a succinct answer. 1.52. What is the ratio of the Number of days in Serbia in 2006 to that in 2011?
Your answer should be very brief. 1.77. What is the ratio of the Number of days of Europe(developing only) in 2007 to that in 2008?
Ensure brevity in your answer.  1.16. What is the ratio of the Number of days of Germany in 2007 to that in 2008?
Make the answer very short. 1.03. What is the ratio of the Number of days in Serbia in 2007 to that in 2008?
Provide a succinct answer. 1. What is the ratio of the Number of days in Europe(developing only) in 2007 to that in 2009?
Make the answer very short. 1.43. What is the ratio of the Number of days of Germany in 2007 to that in 2009?
Give a very brief answer. 1.03. What is the ratio of the Number of days of Hong Kong in 2007 to that in 2009?
Provide a short and direct response. 1.83. What is the ratio of the Number of days in Serbia in 2007 to that in 2009?
Your response must be concise. 1.77. What is the ratio of the Number of days of Europe(developing only) in 2007 to that in 2010?
Ensure brevity in your answer.  1.56. What is the ratio of the Number of days in Germany in 2007 to that in 2010?
Your answer should be very brief. 1.24. What is the ratio of the Number of days in Hong Kong in 2007 to that in 2010?
Keep it short and to the point. 1.83. What is the ratio of the Number of days in Serbia in 2007 to that in 2010?
Make the answer very short. 1.77. What is the ratio of the Number of days of Europe(developing only) in 2007 to that in 2011?
Give a very brief answer. 1.73. What is the ratio of the Number of days of Germany in 2007 to that in 2011?
Provide a succinct answer. 1.24. What is the ratio of the Number of days in Serbia in 2007 to that in 2011?
Provide a succinct answer. 1.77. What is the ratio of the Number of days in Europe(developing only) in 2008 to that in 2009?
Offer a terse response. 1.23. What is the ratio of the Number of days of Hong Kong in 2008 to that in 2009?
Keep it short and to the point. 1.83. What is the ratio of the Number of days in Serbia in 2008 to that in 2009?
Your answer should be compact. 1.77. What is the ratio of the Number of days of Europe(developing only) in 2008 to that in 2010?
Your answer should be compact. 1.34. What is the ratio of the Number of days in Germany in 2008 to that in 2010?
Your answer should be compact. 1.21. What is the ratio of the Number of days in Hong Kong in 2008 to that in 2010?
Give a very brief answer. 1.83. What is the ratio of the Number of days in Serbia in 2008 to that in 2010?
Your answer should be compact. 1.77. What is the ratio of the Number of days in Europe(developing only) in 2008 to that in 2011?
Provide a short and direct response. 1.49. What is the ratio of the Number of days in Germany in 2008 to that in 2011?
Offer a very short reply. 1.21. What is the ratio of the Number of days in Serbia in 2008 to that in 2011?
Make the answer very short. 1.77. What is the ratio of the Number of days of Europe(developing only) in 2009 to that in 2010?
Keep it short and to the point. 1.09. What is the ratio of the Number of days of Germany in 2009 to that in 2010?
Keep it short and to the point. 1.21. What is the ratio of the Number of days in Hong Kong in 2009 to that in 2010?
Ensure brevity in your answer.  1. What is the ratio of the Number of days of Europe(developing only) in 2009 to that in 2011?
Offer a very short reply. 1.21. What is the ratio of the Number of days in Germany in 2009 to that in 2011?
Give a very brief answer. 1.21. What is the ratio of the Number of days of Europe(developing only) in 2010 to that in 2011?
Ensure brevity in your answer.  1.11. What is the ratio of the Number of days in Germany in 2010 to that in 2011?
Ensure brevity in your answer.  1. What is the ratio of the Number of days of Serbia in 2010 to that in 2011?
Make the answer very short. 1. What is the difference between the highest and the second highest Number of days in Europe(developing only)?
Ensure brevity in your answer.  0.35. What is the difference between the highest and the lowest Number of days in Europe(developing only)?
Keep it short and to the point. 24.57. What is the difference between the highest and the lowest Number of days in Germany?
Offer a terse response. 30.5. 